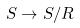Convert formula to latex. <formula><loc_0><loc_0><loc_500><loc_500>S \rightarrow S / R</formula> 